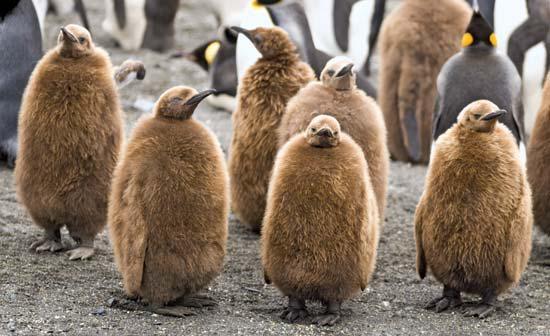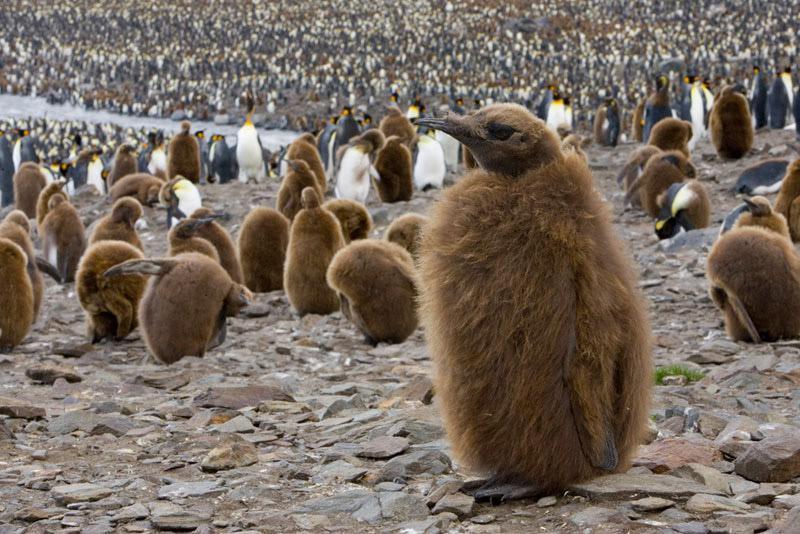The first image is the image on the left, the second image is the image on the right. Evaluate the accuracy of this statement regarding the images: "In the right image, a fuzzy brown penguin stands by itself, with other penguins in the background.". Is it true? Answer yes or no. Yes. The first image is the image on the left, the second image is the image on the right. For the images shown, is this caption "One of the images contains visible grass." true? Answer yes or no. No. 